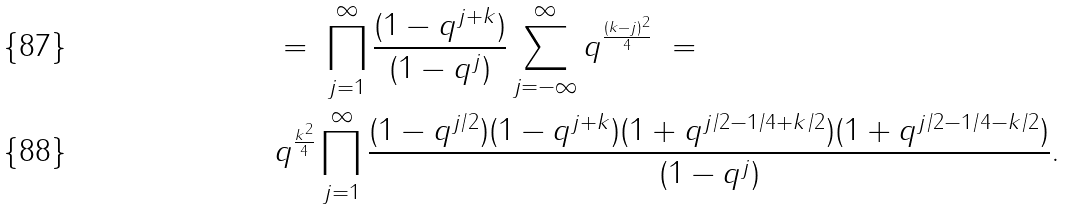Convert formula to latex. <formula><loc_0><loc_0><loc_500><loc_500>& = \ \prod _ { j = 1 } ^ { \infty } \frac { ( 1 - q ^ { j + k } ) } { ( 1 - q ^ { j } ) } \sum _ { j = - \infty } ^ { \infty } q ^ { \frac { ( k - j ) ^ { 2 } } { 4 } } \ = \\ & q ^ { \frac { k ^ { 2 } } { 4 } } \prod _ { j = 1 } ^ { \infty } \frac { ( 1 - q ^ { j / 2 } ) ( 1 - q ^ { j + k } ) ( 1 + q ^ { j / 2 - 1 / 4 + k / 2 } ) ( 1 + q ^ { j / 2 - 1 / 4 - k / 2 } ) } { ( 1 - q ^ { j } ) } .</formula> 